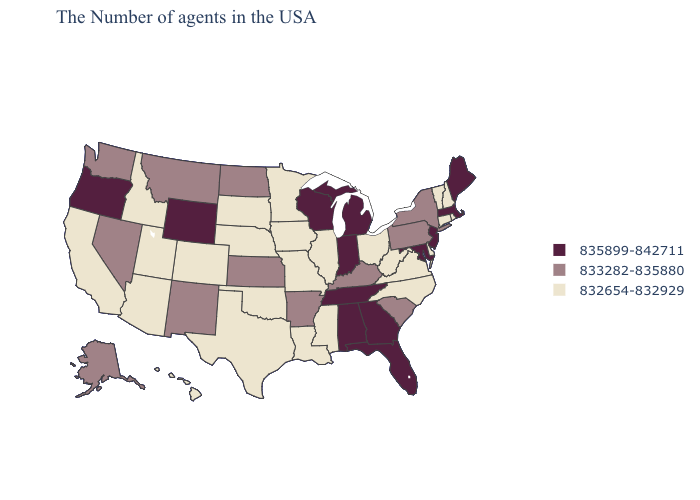What is the value of Kentucky?
Be succinct. 833282-835880. What is the value of Montana?
Short answer required. 833282-835880. Which states have the lowest value in the South?
Short answer required. Delaware, Virginia, North Carolina, West Virginia, Mississippi, Louisiana, Oklahoma, Texas. Does Hawaii have a lower value than Missouri?
Keep it brief. No. Name the states that have a value in the range 832654-832929?
Quick response, please. Rhode Island, New Hampshire, Vermont, Connecticut, Delaware, Virginia, North Carolina, West Virginia, Ohio, Illinois, Mississippi, Louisiana, Missouri, Minnesota, Iowa, Nebraska, Oklahoma, Texas, South Dakota, Colorado, Utah, Arizona, Idaho, California, Hawaii. Name the states that have a value in the range 835899-842711?
Answer briefly. Maine, Massachusetts, New Jersey, Maryland, Florida, Georgia, Michigan, Indiana, Alabama, Tennessee, Wisconsin, Wyoming, Oregon. What is the lowest value in the MidWest?
Short answer required. 832654-832929. What is the value of Alabama?
Write a very short answer. 835899-842711. Which states hav the highest value in the South?
Concise answer only. Maryland, Florida, Georgia, Alabama, Tennessee. What is the value of Alabama?
Give a very brief answer. 835899-842711. What is the lowest value in the USA?
Answer briefly. 832654-832929. What is the value of North Carolina?
Quick response, please. 832654-832929. Does Delaware have a lower value than Virginia?
Give a very brief answer. No. What is the value of North Carolina?
Keep it brief. 832654-832929. Does North Carolina have a higher value than Indiana?
Write a very short answer. No. 